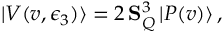<formula> <loc_0><loc_0><loc_500><loc_500>| V ( v , \epsilon _ { 3 } ) \rangle = 2 \, { S } _ { Q } ^ { 3 } \, | P ( v ) \rangle \, ,</formula> 